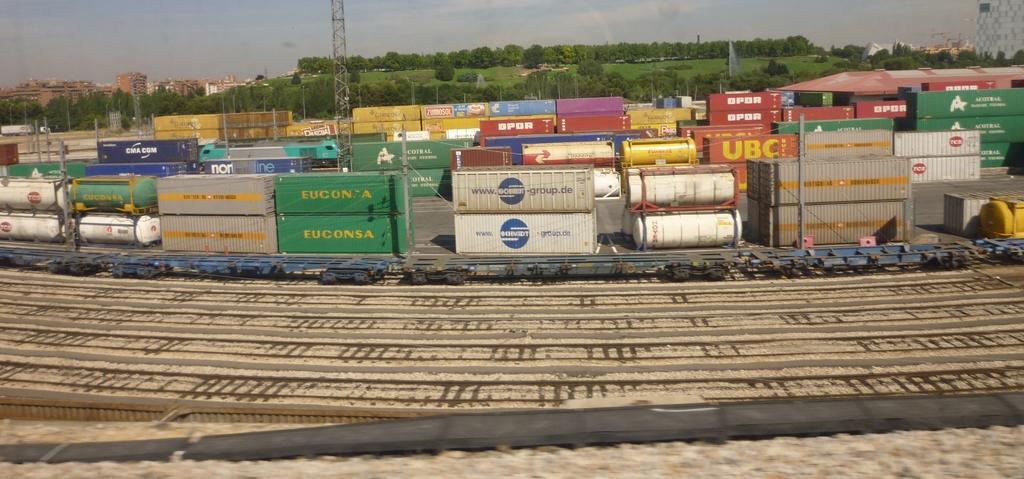What company is on the closest green container?
Your answer should be very brief. Euconsa. What company is on the red container?
Provide a succinct answer. Unanswerable. 